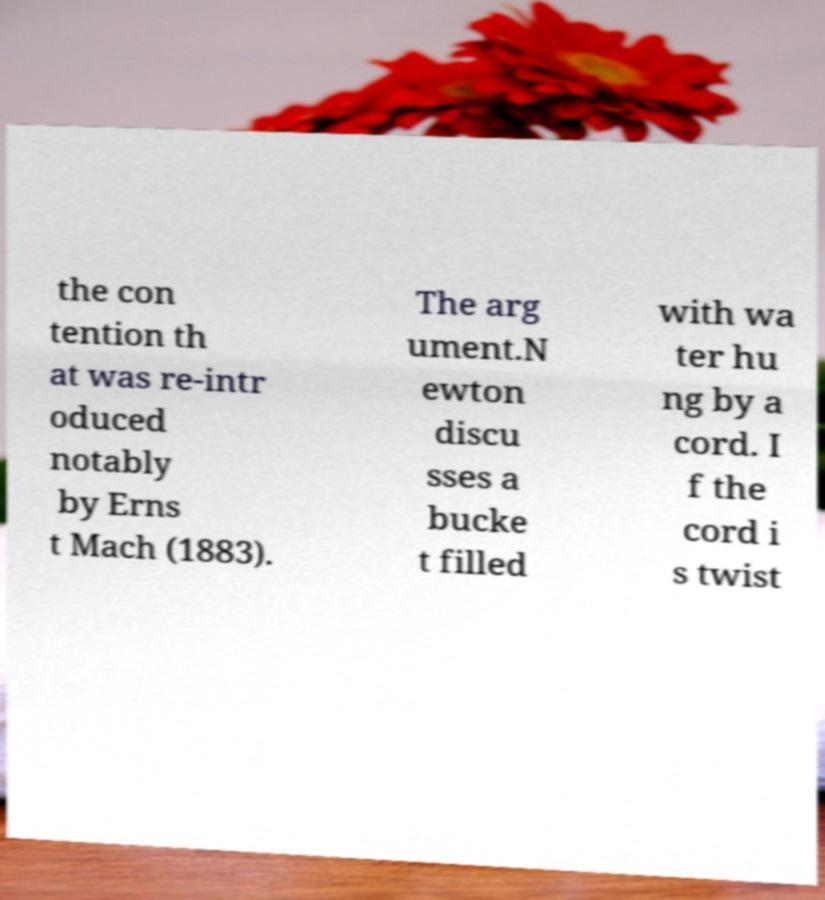Please identify and transcribe the text found in this image. the con tention th at was re-intr oduced notably by Erns t Mach (1883). The arg ument.N ewton discu sses a bucke t filled with wa ter hu ng by a cord. I f the cord i s twist 